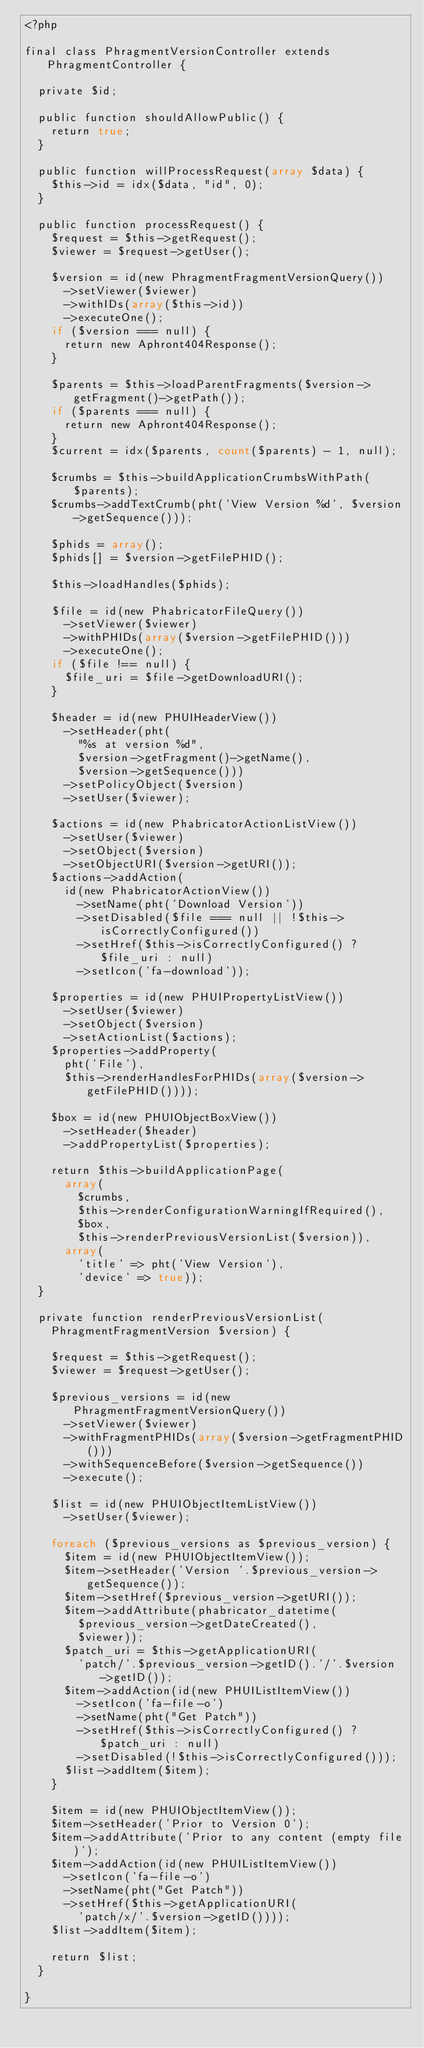Convert code to text. <code><loc_0><loc_0><loc_500><loc_500><_PHP_><?php

final class PhragmentVersionController extends PhragmentController {

  private $id;

  public function shouldAllowPublic() {
    return true;
  }

  public function willProcessRequest(array $data) {
    $this->id = idx($data, "id", 0);
  }

  public function processRequest() {
    $request = $this->getRequest();
    $viewer = $request->getUser();

    $version = id(new PhragmentFragmentVersionQuery())
      ->setViewer($viewer)
      ->withIDs(array($this->id))
      ->executeOne();
    if ($version === null) {
      return new Aphront404Response();
    }

    $parents = $this->loadParentFragments($version->getFragment()->getPath());
    if ($parents === null) {
      return new Aphront404Response();
    }
    $current = idx($parents, count($parents) - 1, null);

    $crumbs = $this->buildApplicationCrumbsWithPath($parents);
    $crumbs->addTextCrumb(pht('View Version %d', $version->getSequence()));

    $phids = array();
    $phids[] = $version->getFilePHID();

    $this->loadHandles($phids);

    $file = id(new PhabricatorFileQuery())
      ->setViewer($viewer)
      ->withPHIDs(array($version->getFilePHID()))
      ->executeOne();
    if ($file !== null) {
      $file_uri = $file->getDownloadURI();
    }

    $header = id(new PHUIHeaderView())
      ->setHeader(pht(
        "%s at version %d",
        $version->getFragment()->getName(),
        $version->getSequence()))
      ->setPolicyObject($version)
      ->setUser($viewer);

    $actions = id(new PhabricatorActionListView())
      ->setUser($viewer)
      ->setObject($version)
      ->setObjectURI($version->getURI());
    $actions->addAction(
      id(new PhabricatorActionView())
        ->setName(pht('Download Version'))
        ->setDisabled($file === null || !$this->isCorrectlyConfigured())
        ->setHref($this->isCorrectlyConfigured() ? $file_uri : null)
        ->setIcon('fa-download'));

    $properties = id(new PHUIPropertyListView())
      ->setUser($viewer)
      ->setObject($version)
      ->setActionList($actions);
    $properties->addProperty(
      pht('File'),
      $this->renderHandlesForPHIDs(array($version->getFilePHID())));

    $box = id(new PHUIObjectBoxView())
      ->setHeader($header)
      ->addPropertyList($properties);

    return $this->buildApplicationPage(
      array(
        $crumbs,
        $this->renderConfigurationWarningIfRequired(),
        $box,
        $this->renderPreviousVersionList($version)),
      array(
        'title' => pht('View Version'),
        'device' => true));
  }

  private function renderPreviousVersionList(
    PhragmentFragmentVersion $version) {

    $request = $this->getRequest();
    $viewer = $request->getUser();

    $previous_versions = id(new PhragmentFragmentVersionQuery())
      ->setViewer($viewer)
      ->withFragmentPHIDs(array($version->getFragmentPHID()))
      ->withSequenceBefore($version->getSequence())
      ->execute();

    $list = id(new PHUIObjectItemListView())
      ->setUser($viewer);

    foreach ($previous_versions as $previous_version) {
      $item = id(new PHUIObjectItemView());
      $item->setHeader('Version '.$previous_version->getSequence());
      $item->setHref($previous_version->getURI());
      $item->addAttribute(phabricator_datetime(
        $previous_version->getDateCreated(),
        $viewer));
      $patch_uri = $this->getApplicationURI(
        'patch/'.$previous_version->getID().'/'.$version->getID());
      $item->addAction(id(new PHUIListItemView())
        ->setIcon('fa-file-o')
        ->setName(pht("Get Patch"))
        ->setHref($this->isCorrectlyConfigured() ? $patch_uri : null)
        ->setDisabled(!$this->isCorrectlyConfigured()));
      $list->addItem($item);
    }

    $item = id(new PHUIObjectItemView());
    $item->setHeader('Prior to Version 0');
    $item->addAttribute('Prior to any content (empty file)');
    $item->addAction(id(new PHUIListItemView())
      ->setIcon('fa-file-o')
      ->setName(pht("Get Patch"))
      ->setHref($this->getApplicationURI(
        'patch/x/'.$version->getID())));
    $list->addItem($item);

    return $list;
  }

}
</code> 